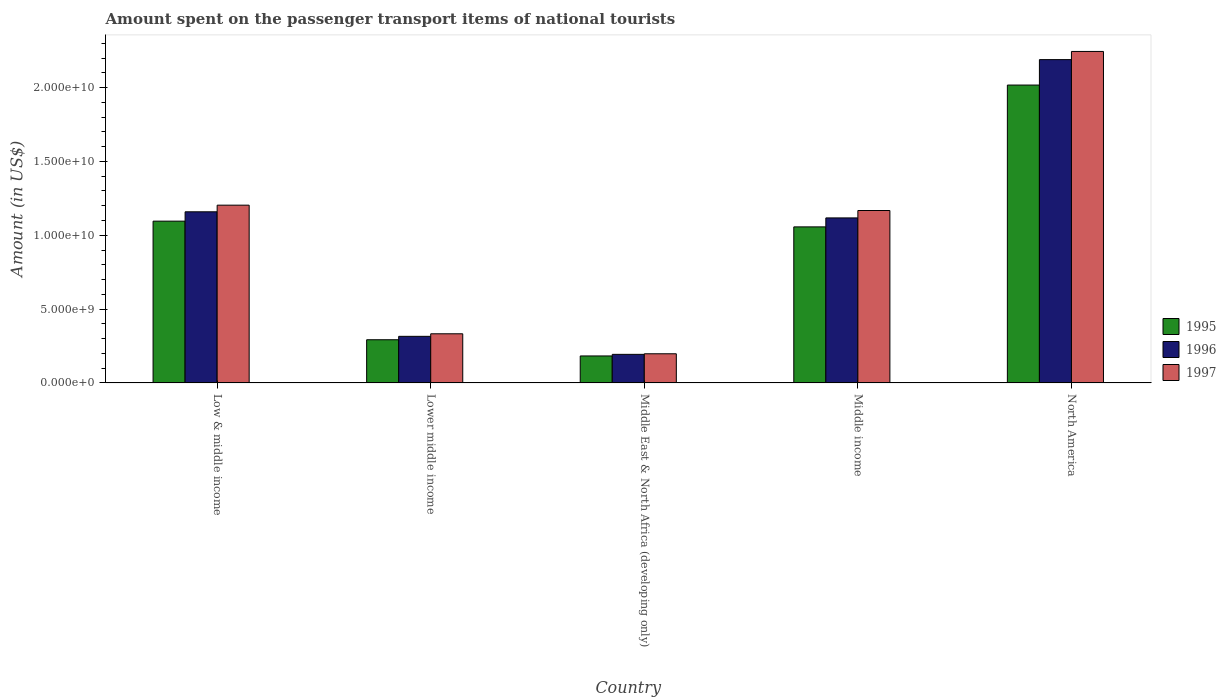How many different coloured bars are there?
Offer a very short reply. 3. Are the number of bars per tick equal to the number of legend labels?
Make the answer very short. Yes. How many bars are there on the 2nd tick from the left?
Your response must be concise. 3. How many bars are there on the 3rd tick from the right?
Your answer should be compact. 3. What is the label of the 4th group of bars from the left?
Your answer should be very brief. Middle income. What is the amount spent on the passenger transport items of national tourists in 1995 in Middle income?
Provide a succinct answer. 1.06e+1. Across all countries, what is the maximum amount spent on the passenger transport items of national tourists in 1997?
Offer a terse response. 2.24e+1. Across all countries, what is the minimum amount spent on the passenger transport items of national tourists in 1995?
Keep it short and to the point. 1.83e+09. In which country was the amount spent on the passenger transport items of national tourists in 1996 maximum?
Offer a very short reply. North America. In which country was the amount spent on the passenger transport items of national tourists in 1996 minimum?
Your response must be concise. Middle East & North Africa (developing only). What is the total amount spent on the passenger transport items of national tourists in 1997 in the graph?
Your response must be concise. 5.15e+1. What is the difference between the amount spent on the passenger transport items of national tourists in 1995 in Lower middle income and that in Middle income?
Your answer should be compact. -7.64e+09. What is the difference between the amount spent on the passenger transport items of national tourists in 1996 in Low & middle income and the amount spent on the passenger transport items of national tourists in 1997 in Middle East & North Africa (developing only)?
Ensure brevity in your answer.  9.61e+09. What is the average amount spent on the passenger transport items of national tourists in 1996 per country?
Ensure brevity in your answer.  9.95e+09. What is the difference between the amount spent on the passenger transport items of national tourists of/in 1995 and amount spent on the passenger transport items of national tourists of/in 1997 in Lower middle income?
Provide a succinct answer. -4.03e+08. In how many countries, is the amount spent on the passenger transport items of national tourists in 1997 greater than 9000000000 US$?
Offer a terse response. 3. What is the ratio of the amount spent on the passenger transport items of national tourists in 1997 in Lower middle income to that in North America?
Keep it short and to the point. 0.15. Is the amount spent on the passenger transport items of national tourists in 1997 in Low & middle income less than that in Middle East & North Africa (developing only)?
Your answer should be compact. No. Is the difference between the amount spent on the passenger transport items of national tourists in 1995 in Low & middle income and Middle East & North Africa (developing only) greater than the difference between the amount spent on the passenger transport items of national tourists in 1997 in Low & middle income and Middle East & North Africa (developing only)?
Provide a succinct answer. No. What is the difference between the highest and the second highest amount spent on the passenger transport items of national tourists in 1995?
Your answer should be compact. -9.21e+09. What is the difference between the highest and the lowest amount spent on the passenger transport items of national tourists in 1996?
Give a very brief answer. 2.00e+1. In how many countries, is the amount spent on the passenger transport items of national tourists in 1997 greater than the average amount spent on the passenger transport items of national tourists in 1997 taken over all countries?
Your response must be concise. 3. Is the sum of the amount spent on the passenger transport items of national tourists in 1997 in Low & middle income and Lower middle income greater than the maximum amount spent on the passenger transport items of national tourists in 1996 across all countries?
Ensure brevity in your answer.  No. What does the 3rd bar from the right in Low & middle income represents?
Ensure brevity in your answer.  1995. Is it the case that in every country, the sum of the amount spent on the passenger transport items of national tourists in 1997 and amount spent on the passenger transport items of national tourists in 1995 is greater than the amount spent on the passenger transport items of national tourists in 1996?
Make the answer very short. Yes. What is the difference between two consecutive major ticks on the Y-axis?
Make the answer very short. 5.00e+09. Does the graph contain grids?
Provide a short and direct response. No. Where does the legend appear in the graph?
Provide a short and direct response. Center right. How many legend labels are there?
Give a very brief answer. 3. What is the title of the graph?
Your answer should be compact. Amount spent on the passenger transport items of national tourists. Does "2006" appear as one of the legend labels in the graph?
Keep it short and to the point. No. What is the label or title of the X-axis?
Give a very brief answer. Country. What is the Amount (in US$) in 1995 in Low & middle income?
Provide a short and direct response. 1.10e+1. What is the Amount (in US$) in 1996 in Low & middle income?
Give a very brief answer. 1.16e+1. What is the Amount (in US$) in 1997 in Low & middle income?
Give a very brief answer. 1.20e+1. What is the Amount (in US$) of 1995 in Lower middle income?
Ensure brevity in your answer.  2.92e+09. What is the Amount (in US$) in 1996 in Lower middle income?
Your answer should be very brief. 3.16e+09. What is the Amount (in US$) in 1997 in Lower middle income?
Give a very brief answer. 3.33e+09. What is the Amount (in US$) of 1995 in Middle East & North Africa (developing only)?
Offer a terse response. 1.83e+09. What is the Amount (in US$) of 1996 in Middle East & North Africa (developing only)?
Keep it short and to the point. 1.94e+09. What is the Amount (in US$) of 1997 in Middle East & North Africa (developing only)?
Provide a succinct answer. 1.97e+09. What is the Amount (in US$) in 1995 in Middle income?
Make the answer very short. 1.06e+1. What is the Amount (in US$) in 1996 in Middle income?
Keep it short and to the point. 1.12e+1. What is the Amount (in US$) of 1997 in Middle income?
Offer a very short reply. 1.17e+1. What is the Amount (in US$) of 1995 in North America?
Offer a terse response. 2.02e+1. What is the Amount (in US$) in 1996 in North America?
Your answer should be compact. 2.19e+1. What is the Amount (in US$) of 1997 in North America?
Your response must be concise. 2.24e+1. Across all countries, what is the maximum Amount (in US$) in 1995?
Offer a very short reply. 2.02e+1. Across all countries, what is the maximum Amount (in US$) of 1996?
Ensure brevity in your answer.  2.19e+1. Across all countries, what is the maximum Amount (in US$) of 1997?
Offer a terse response. 2.24e+1. Across all countries, what is the minimum Amount (in US$) in 1995?
Your answer should be compact. 1.83e+09. Across all countries, what is the minimum Amount (in US$) in 1996?
Give a very brief answer. 1.94e+09. Across all countries, what is the minimum Amount (in US$) in 1997?
Your answer should be compact. 1.97e+09. What is the total Amount (in US$) in 1995 in the graph?
Provide a short and direct response. 4.64e+1. What is the total Amount (in US$) in 1996 in the graph?
Your answer should be compact. 4.97e+1. What is the total Amount (in US$) of 1997 in the graph?
Provide a short and direct response. 5.15e+1. What is the difference between the Amount (in US$) in 1995 in Low & middle income and that in Lower middle income?
Give a very brief answer. 8.03e+09. What is the difference between the Amount (in US$) in 1996 in Low & middle income and that in Lower middle income?
Give a very brief answer. 8.43e+09. What is the difference between the Amount (in US$) of 1997 in Low & middle income and that in Lower middle income?
Offer a very short reply. 8.71e+09. What is the difference between the Amount (in US$) in 1995 in Low & middle income and that in Middle East & North Africa (developing only)?
Give a very brief answer. 9.13e+09. What is the difference between the Amount (in US$) of 1996 in Low & middle income and that in Middle East & North Africa (developing only)?
Provide a succinct answer. 9.65e+09. What is the difference between the Amount (in US$) in 1997 in Low & middle income and that in Middle East & North Africa (developing only)?
Provide a short and direct response. 1.01e+1. What is the difference between the Amount (in US$) of 1995 in Low & middle income and that in Middle income?
Provide a succinct answer. 3.88e+08. What is the difference between the Amount (in US$) in 1996 in Low & middle income and that in Middle income?
Ensure brevity in your answer.  4.14e+08. What is the difference between the Amount (in US$) in 1997 in Low & middle income and that in Middle income?
Offer a very short reply. 3.62e+08. What is the difference between the Amount (in US$) in 1995 in Low & middle income and that in North America?
Provide a short and direct response. -9.21e+09. What is the difference between the Amount (in US$) of 1996 in Low & middle income and that in North America?
Provide a succinct answer. -1.03e+1. What is the difference between the Amount (in US$) in 1997 in Low & middle income and that in North America?
Make the answer very short. -1.04e+1. What is the difference between the Amount (in US$) in 1995 in Lower middle income and that in Middle East & North Africa (developing only)?
Offer a terse response. 1.10e+09. What is the difference between the Amount (in US$) in 1996 in Lower middle income and that in Middle East & North Africa (developing only)?
Make the answer very short. 1.22e+09. What is the difference between the Amount (in US$) of 1997 in Lower middle income and that in Middle East & North Africa (developing only)?
Your response must be concise. 1.35e+09. What is the difference between the Amount (in US$) of 1995 in Lower middle income and that in Middle income?
Offer a terse response. -7.64e+09. What is the difference between the Amount (in US$) of 1996 in Lower middle income and that in Middle income?
Offer a terse response. -8.02e+09. What is the difference between the Amount (in US$) in 1997 in Lower middle income and that in Middle income?
Your answer should be very brief. -8.35e+09. What is the difference between the Amount (in US$) in 1995 in Lower middle income and that in North America?
Ensure brevity in your answer.  -1.72e+1. What is the difference between the Amount (in US$) in 1996 in Lower middle income and that in North America?
Give a very brief answer. -1.87e+1. What is the difference between the Amount (in US$) of 1997 in Lower middle income and that in North America?
Give a very brief answer. -1.91e+1. What is the difference between the Amount (in US$) of 1995 in Middle East & North Africa (developing only) and that in Middle income?
Your response must be concise. -8.74e+09. What is the difference between the Amount (in US$) in 1996 in Middle East & North Africa (developing only) and that in Middle income?
Provide a succinct answer. -9.24e+09. What is the difference between the Amount (in US$) of 1997 in Middle East & North Africa (developing only) and that in Middle income?
Ensure brevity in your answer.  -9.70e+09. What is the difference between the Amount (in US$) of 1995 in Middle East & North Africa (developing only) and that in North America?
Keep it short and to the point. -1.83e+1. What is the difference between the Amount (in US$) of 1996 in Middle East & North Africa (developing only) and that in North America?
Provide a succinct answer. -2.00e+1. What is the difference between the Amount (in US$) in 1997 in Middle East & North Africa (developing only) and that in North America?
Offer a very short reply. -2.05e+1. What is the difference between the Amount (in US$) in 1995 in Middle income and that in North America?
Ensure brevity in your answer.  -9.60e+09. What is the difference between the Amount (in US$) of 1996 in Middle income and that in North America?
Make the answer very short. -1.07e+1. What is the difference between the Amount (in US$) of 1997 in Middle income and that in North America?
Keep it short and to the point. -1.08e+1. What is the difference between the Amount (in US$) of 1995 in Low & middle income and the Amount (in US$) of 1996 in Lower middle income?
Make the answer very short. 7.80e+09. What is the difference between the Amount (in US$) of 1995 in Low & middle income and the Amount (in US$) of 1997 in Lower middle income?
Provide a succinct answer. 7.63e+09. What is the difference between the Amount (in US$) of 1996 in Low & middle income and the Amount (in US$) of 1997 in Lower middle income?
Keep it short and to the point. 8.26e+09. What is the difference between the Amount (in US$) in 1995 in Low & middle income and the Amount (in US$) in 1996 in Middle East & North Africa (developing only)?
Provide a short and direct response. 9.02e+09. What is the difference between the Amount (in US$) in 1995 in Low & middle income and the Amount (in US$) in 1997 in Middle East & North Africa (developing only)?
Provide a succinct answer. 8.98e+09. What is the difference between the Amount (in US$) of 1996 in Low & middle income and the Amount (in US$) of 1997 in Middle East & North Africa (developing only)?
Keep it short and to the point. 9.61e+09. What is the difference between the Amount (in US$) in 1995 in Low & middle income and the Amount (in US$) in 1996 in Middle income?
Provide a short and direct response. -2.19e+08. What is the difference between the Amount (in US$) of 1995 in Low & middle income and the Amount (in US$) of 1997 in Middle income?
Offer a terse response. -7.20e+08. What is the difference between the Amount (in US$) of 1996 in Low & middle income and the Amount (in US$) of 1997 in Middle income?
Give a very brief answer. -8.74e+07. What is the difference between the Amount (in US$) of 1995 in Low & middle income and the Amount (in US$) of 1996 in North America?
Provide a succinct answer. -1.09e+1. What is the difference between the Amount (in US$) in 1995 in Low & middle income and the Amount (in US$) in 1997 in North America?
Offer a terse response. -1.15e+1. What is the difference between the Amount (in US$) of 1996 in Low & middle income and the Amount (in US$) of 1997 in North America?
Make the answer very short. -1.09e+1. What is the difference between the Amount (in US$) in 1995 in Lower middle income and the Amount (in US$) in 1996 in Middle East & North Africa (developing only)?
Keep it short and to the point. 9.90e+08. What is the difference between the Amount (in US$) in 1995 in Lower middle income and the Amount (in US$) in 1997 in Middle East & North Africa (developing only)?
Provide a succinct answer. 9.50e+08. What is the difference between the Amount (in US$) of 1996 in Lower middle income and the Amount (in US$) of 1997 in Middle East & North Africa (developing only)?
Provide a short and direct response. 1.18e+09. What is the difference between the Amount (in US$) of 1995 in Lower middle income and the Amount (in US$) of 1996 in Middle income?
Your answer should be compact. -8.25e+09. What is the difference between the Amount (in US$) in 1995 in Lower middle income and the Amount (in US$) in 1997 in Middle income?
Keep it short and to the point. -8.75e+09. What is the difference between the Amount (in US$) of 1996 in Lower middle income and the Amount (in US$) of 1997 in Middle income?
Give a very brief answer. -8.52e+09. What is the difference between the Amount (in US$) in 1995 in Lower middle income and the Amount (in US$) in 1996 in North America?
Provide a succinct answer. -1.90e+1. What is the difference between the Amount (in US$) of 1995 in Lower middle income and the Amount (in US$) of 1997 in North America?
Ensure brevity in your answer.  -1.95e+1. What is the difference between the Amount (in US$) of 1996 in Lower middle income and the Amount (in US$) of 1997 in North America?
Your answer should be very brief. -1.93e+1. What is the difference between the Amount (in US$) of 1995 in Middle East & North Africa (developing only) and the Amount (in US$) of 1996 in Middle income?
Provide a short and direct response. -9.35e+09. What is the difference between the Amount (in US$) of 1995 in Middle East & North Africa (developing only) and the Amount (in US$) of 1997 in Middle income?
Offer a very short reply. -9.85e+09. What is the difference between the Amount (in US$) in 1996 in Middle East & North Africa (developing only) and the Amount (in US$) in 1997 in Middle income?
Make the answer very short. -9.74e+09. What is the difference between the Amount (in US$) of 1995 in Middle East & North Africa (developing only) and the Amount (in US$) of 1996 in North America?
Give a very brief answer. -2.01e+1. What is the difference between the Amount (in US$) of 1995 in Middle East & North Africa (developing only) and the Amount (in US$) of 1997 in North America?
Keep it short and to the point. -2.06e+1. What is the difference between the Amount (in US$) in 1996 in Middle East & North Africa (developing only) and the Amount (in US$) in 1997 in North America?
Provide a short and direct response. -2.05e+1. What is the difference between the Amount (in US$) of 1995 in Middle income and the Amount (in US$) of 1996 in North America?
Provide a short and direct response. -1.13e+1. What is the difference between the Amount (in US$) of 1995 in Middle income and the Amount (in US$) of 1997 in North America?
Provide a succinct answer. -1.19e+1. What is the difference between the Amount (in US$) in 1996 in Middle income and the Amount (in US$) in 1997 in North America?
Offer a terse response. -1.13e+1. What is the average Amount (in US$) in 1995 per country?
Your answer should be very brief. 9.29e+09. What is the average Amount (in US$) of 1996 per country?
Offer a terse response. 9.95e+09. What is the average Amount (in US$) of 1997 per country?
Your answer should be compact. 1.03e+1. What is the difference between the Amount (in US$) in 1995 and Amount (in US$) in 1996 in Low & middle income?
Make the answer very short. -6.33e+08. What is the difference between the Amount (in US$) of 1995 and Amount (in US$) of 1997 in Low & middle income?
Make the answer very short. -1.08e+09. What is the difference between the Amount (in US$) in 1996 and Amount (in US$) in 1997 in Low & middle income?
Provide a succinct answer. -4.49e+08. What is the difference between the Amount (in US$) in 1995 and Amount (in US$) in 1996 in Lower middle income?
Your response must be concise. -2.31e+08. What is the difference between the Amount (in US$) of 1995 and Amount (in US$) of 1997 in Lower middle income?
Keep it short and to the point. -4.03e+08. What is the difference between the Amount (in US$) of 1996 and Amount (in US$) of 1997 in Lower middle income?
Your answer should be very brief. -1.73e+08. What is the difference between the Amount (in US$) in 1995 and Amount (in US$) in 1996 in Middle East & North Africa (developing only)?
Keep it short and to the point. -1.08e+08. What is the difference between the Amount (in US$) in 1995 and Amount (in US$) in 1997 in Middle East & North Africa (developing only)?
Your response must be concise. -1.47e+08. What is the difference between the Amount (in US$) in 1996 and Amount (in US$) in 1997 in Middle East & North Africa (developing only)?
Your response must be concise. -3.92e+07. What is the difference between the Amount (in US$) of 1995 and Amount (in US$) of 1996 in Middle income?
Make the answer very short. -6.08e+08. What is the difference between the Amount (in US$) in 1995 and Amount (in US$) in 1997 in Middle income?
Provide a succinct answer. -1.11e+09. What is the difference between the Amount (in US$) of 1996 and Amount (in US$) of 1997 in Middle income?
Offer a terse response. -5.01e+08. What is the difference between the Amount (in US$) in 1995 and Amount (in US$) in 1996 in North America?
Your response must be concise. -1.72e+09. What is the difference between the Amount (in US$) of 1995 and Amount (in US$) of 1997 in North America?
Ensure brevity in your answer.  -2.28e+09. What is the difference between the Amount (in US$) in 1996 and Amount (in US$) in 1997 in North America?
Your answer should be very brief. -5.53e+08. What is the ratio of the Amount (in US$) of 1995 in Low & middle income to that in Lower middle income?
Provide a short and direct response. 3.75. What is the ratio of the Amount (in US$) of 1996 in Low & middle income to that in Lower middle income?
Offer a terse response. 3.67. What is the ratio of the Amount (in US$) of 1997 in Low & middle income to that in Lower middle income?
Make the answer very short. 3.62. What is the ratio of the Amount (in US$) in 1995 in Low & middle income to that in Middle East & North Africa (developing only)?
Provide a short and direct response. 5.99. What is the ratio of the Amount (in US$) of 1996 in Low & middle income to that in Middle East & North Africa (developing only)?
Keep it short and to the point. 5.99. What is the ratio of the Amount (in US$) in 1997 in Low & middle income to that in Middle East & North Africa (developing only)?
Provide a short and direct response. 6.1. What is the ratio of the Amount (in US$) of 1995 in Low & middle income to that in Middle income?
Offer a very short reply. 1.04. What is the ratio of the Amount (in US$) of 1997 in Low & middle income to that in Middle income?
Your response must be concise. 1.03. What is the ratio of the Amount (in US$) of 1995 in Low & middle income to that in North America?
Your answer should be compact. 0.54. What is the ratio of the Amount (in US$) in 1996 in Low & middle income to that in North America?
Make the answer very short. 0.53. What is the ratio of the Amount (in US$) of 1997 in Low & middle income to that in North America?
Provide a short and direct response. 0.54. What is the ratio of the Amount (in US$) of 1995 in Lower middle income to that in Middle East & North Africa (developing only)?
Ensure brevity in your answer.  1.6. What is the ratio of the Amount (in US$) in 1996 in Lower middle income to that in Middle East & North Africa (developing only)?
Provide a succinct answer. 1.63. What is the ratio of the Amount (in US$) of 1997 in Lower middle income to that in Middle East & North Africa (developing only)?
Ensure brevity in your answer.  1.69. What is the ratio of the Amount (in US$) in 1995 in Lower middle income to that in Middle income?
Provide a succinct answer. 0.28. What is the ratio of the Amount (in US$) in 1996 in Lower middle income to that in Middle income?
Provide a succinct answer. 0.28. What is the ratio of the Amount (in US$) of 1997 in Lower middle income to that in Middle income?
Keep it short and to the point. 0.29. What is the ratio of the Amount (in US$) of 1995 in Lower middle income to that in North America?
Your answer should be compact. 0.14. What is the ratio of the Amount (in US$) of 1996 in Lower middle income to that in North America?
Keep it short and to the point. 0.14. What is the ratio of the Amount (in US$) in 1997 in Lower middle income to that in North America?
Your response must be concise. 0.15. What is the ratio of the Amount (in US$) in 1995 in Middle East & North Africa (developing only) to that in Middle income?
Your response must be concise. 0.17. What is the ratio of the Amount (in US$) of 1996 in Middle East & North Africa (developing only) to that in Middle income?
Provide a short and direct response. 0.17. What is the ratio of the Amount (in US$) in 1997 in Middle East & North Africa (developing only) to that in Middle income?
Your answer should be very brief. 0.17. What is the ratio of the Amount (in US$) in 1995 in Middle East & North Africa (developing only) to that in North America?
Offer a terse response. 0.09. What is the ratio of the Amount (in US$) of 1996 in Middle East & North Africa (developing only) to that in North America?
Make the answer very short. 0.09. What is the ratio of the Amount (in US$) in 1997 in Middle East & North Africa (developing only) to that in North America?
Provide a succinct answer. 0.09. What is the ratio of the Amount (in US$) in 1995 in Middle income to that in North America?
Your answer should be compact. 0.52. What is the ratio of the Amount (in US$) of 1996 in Middle income to that in North America?
Your answer should be very brief. 0.51. What is the ratio of the Amount (in US$) in 1997 in Middle income to that in North America?
Make the answer very short. 0.52. What is the difference between the highest and the second highest Amount (in US$) of 1995?
Your answer should be compact. 9.21e+09. What is the difference between the highest and the second highest Amount (in US$) in 1996?
Ensure brevity in your answer.  1.03e+1. What is the difference between the highest and the second highest Amount (in US$) in 1997?
Give a very brief answer. 1.04e+1. What is the difference between the highest and the lowest Amount (in US$) of 1995?
Offer a terse response. 1.83e+1. What is the difference between the highest and the lowest Amount (in US$) of 1996?
Offer a terse response. 2.00e+1. What is the difference between the highest and the lowest Amount (in US$) in 1997?
Make the answer very short. 2.05e+1. 